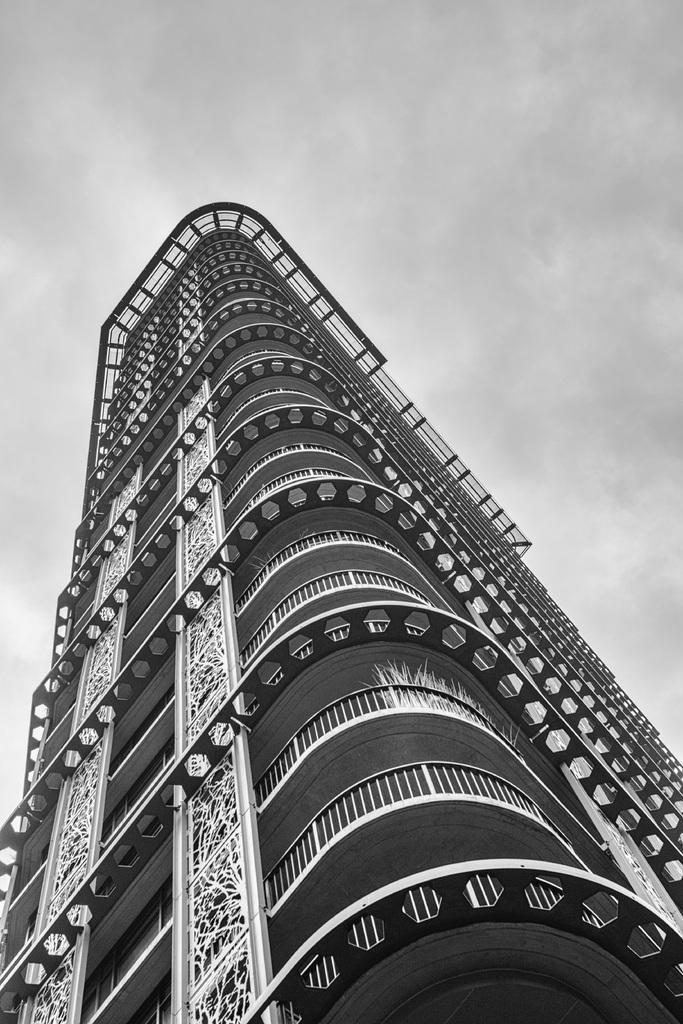How would you summarize this image in a sentence or two? In this picture there is a black and white photo of the big building with the Iron frames and balcony. On the top there is a sky. 